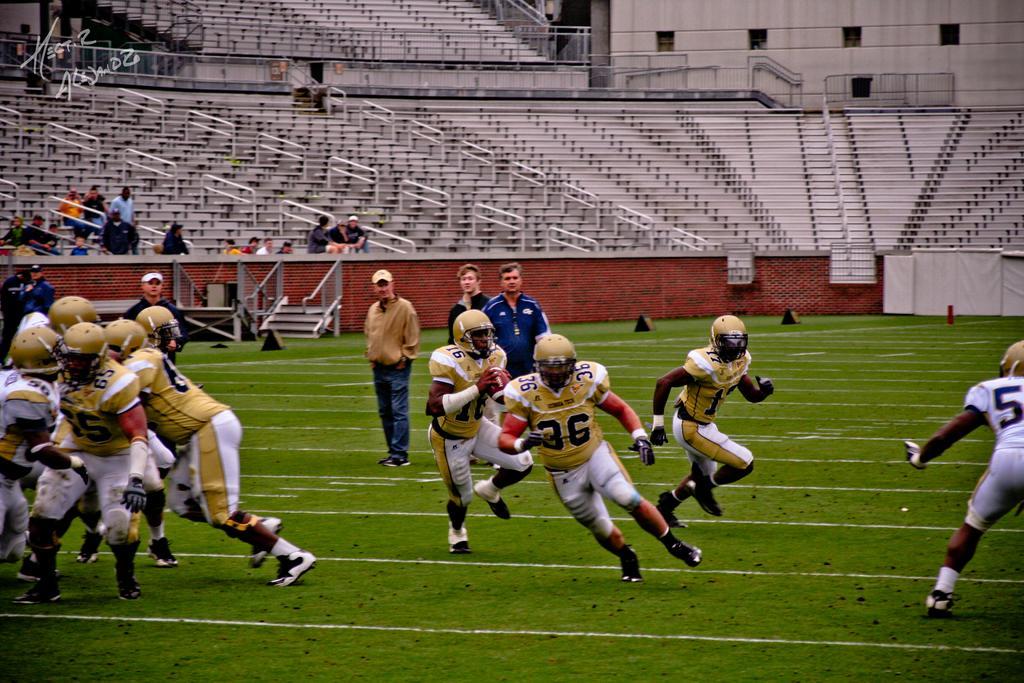Can you describe this image briefly? In this image I can see few persons wearing brown helmet, brown t shirt and white pants are standing and to the right side of the image I can see a person wearing white jersey is standing on the ground. In the background I can see few persons standing on the ground and few of them are wearing caps and I can see the stadium in which I can see few benches and few persons sitting on benches and few persons standing in the stadium. 